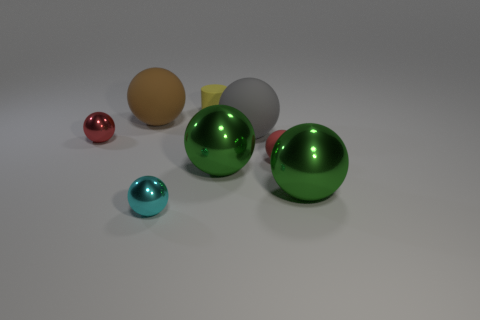What is the lighting like in the scene where these spheres are placed? The lighting in the scene is soft and diffused, with no harsh shadows, indicating an environment that has a well-dispersed light source, possibly from above. This kind of lighting helps to accentuate the reflective properties of the objects and provides a clear view of their colors and textures. 